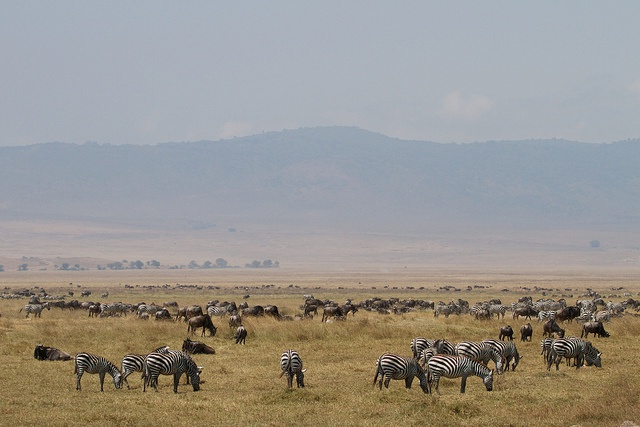Describe the objects in this image and their specific colors. I can see zebra in darkgray, gray, tan, and black tones, zebra in darkgray, black, gray, and tan tones, zebra in darkgray, black, and gray tones, zebra in darkgray, black, and gray tones, and zebra in darkgray, black, and gray tones in this image. 